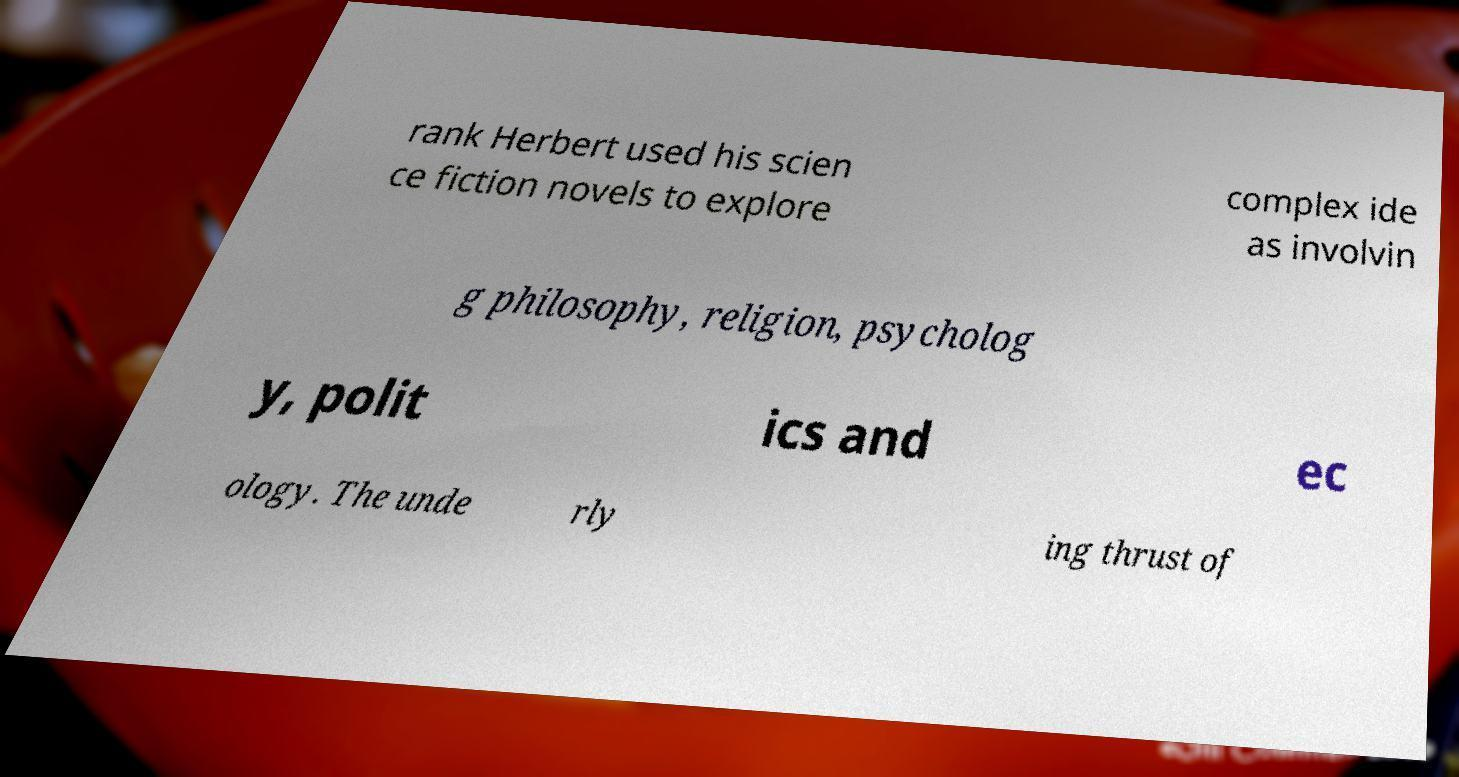For documentation purposes, I need the text within this image transcribed. Could you provide that? rank Herbert used his scien ce fiction novels to explore complex ide as involvin g philosophy, religion, psycholog y, polit ics and ec ology. The unde rly ing thrust of 